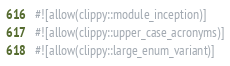<code> <loc_0><loc_0><loc_500><loc_500><_Rust_>#![allow(clippy::module_inception)]
#![allow(clippy::upper_case_acronyms)]
#![allow(clippy::large_enum_variant)]</code> 